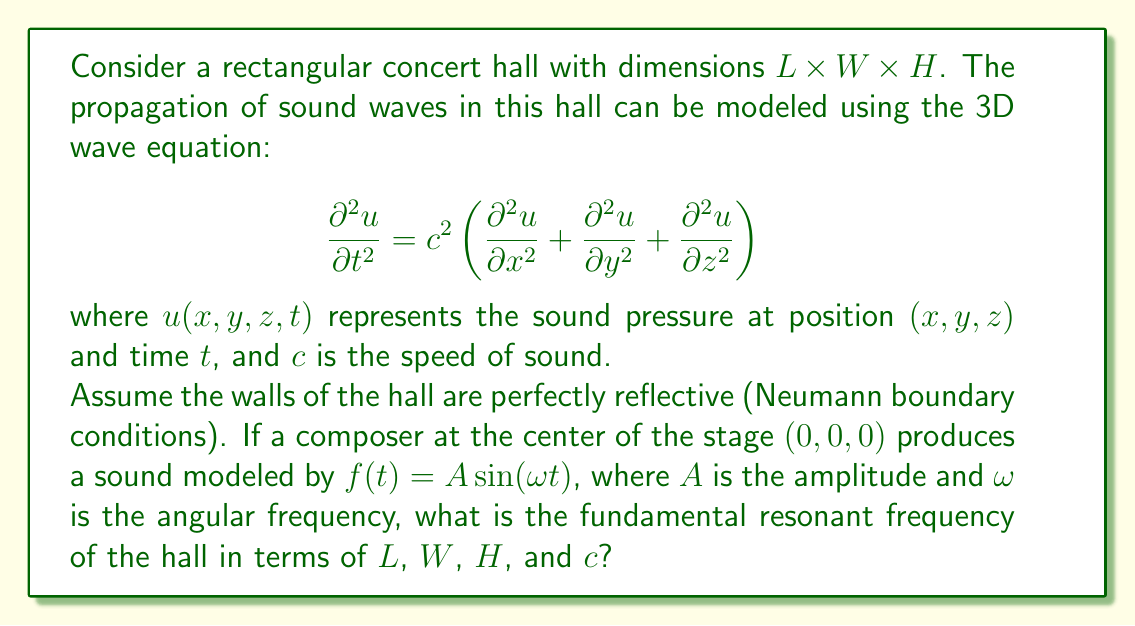Solve this math problem. To solve this problem, we'll follow these steps:

1) For a rectangular room with perfectly reflective walls, the solution to the wave equation can be written as:

   $$u(x,y,z,t) = \sum_{l,m,n} A_{lmn} \cos\left(\frac{l\pi x}{L}\right) \cos\left(\frac{m\pi y}{W}\right) \cos\left(\frac{n\pi z}{H}\right) \cos(\omega_{lmn} t)$$

   where $l$, $m$, and $n$ are non-negative integers.

2) Substituting this into the wave equation, we get:

   $$\omega_{lmn}^2 = c^2 \left[\left(\frac{l\pi}{L}\right)^2 + \left(\frac{m\pi}{W}\right)^2 + \left(\frac{n\pi}{H}\right)^2\right]$$

3) The fundamental frequency corresponds to the lowest non-zero frequency, which occurs when $l=1$, $m=0$, and $n=0$. This gives:

   $$\omega_{100}^2 = c^2 \left(\frac{\pi}{L}\right)^2$$

4) The frequency $f$ is related to the angular frequency $\omega$ by $\omega = 2\pi f$. Therefore:

   $$f_{100} = \frac{\omega_{100}}{2\pi} = \frac{c}{2L}$$

5) This is the fundamental frequency along the length of the hall. Similar expressions can be derived for the width ($f_{010} = \frac{c}{2W}$) and height ($f_{001} = \frac{c}{2H}$).

6) The overall fundamental frequency of the hall will be the lowest of these three frequencies. Since we typically have $L > W > H$ for concert halls, the fundamental frequency will be:

   $$f = \frac{c}{2L}$$

This frequency corresponds to the longest standing wave that can fit in the hall, which would resonate with the length of the hall.
Answer: $f = \frac{c}{2L}$ 